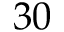Convert formula to latex. <formula><loc_0><loc_0><loc_500><loc_500>3 0</formula> 